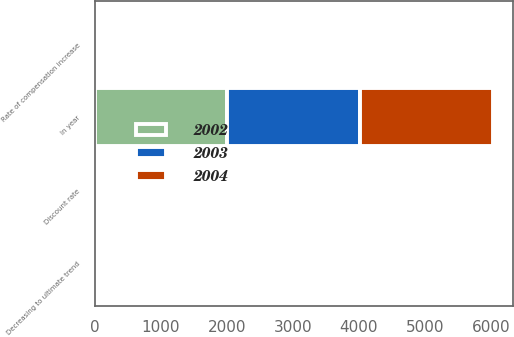Convert chart. <chart><loc_0><loc_0><loc_500><loc_500><stacked_bar_chart><ecel><fcel>Discount rate<fcel>Rate of compensation increase<fcel>Decreasing to ultimate trend<fcel>In year<nl><fcel>2003<fcel>5.75<fcel>3.75<fcel>5<fcel>2009<nl><fcel>2004<fcel>6.25<fcel>3.75<fcel>5<fcel>2009<nl><fcel>2002<fcel>6.75<fcel>4<fcel>5.25<fcel>2007<nl></chart> 